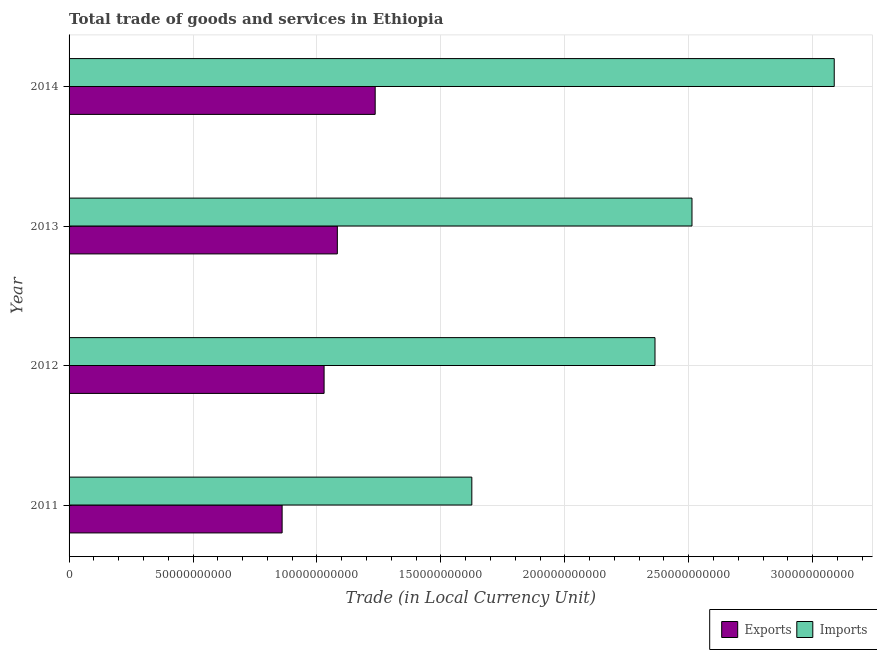How many groups of bars are there?
Give a very brief answer. 4. Are the number of bars per tick equal to the number of legend labels?
Your answer should be very brief. Yes. Are the number of bars on each tick of the Y-axis equal?
Keep it short and to the point. Yes. How many bars are there on the 3rd tick from the top?
Keep it short and to the point. 2. How many bars are there on the 4th tick from the bottom?
Offer a terse response. 2. What is the export of goods and services in 2012?
Provide a short and direct response. 1.03e+11. Across all years, what is the maximum imports of goods and services?
Keep it short and to the point. 3.09e+11. Across all years, what is the minimum imports of goods and services?
Your answer should be compact. 1.62e+11. In which year was the export of goods and services maximum?
Your answer should be very brief. 2014. In which year was the imports of goods and services minimum?
Your answer should be very brief. 2011. What is the total imports of goods and services in the graph?
Offer a very short reply. 9.59e+11. What is the difference between the imports of goods and services in 2011 and that in 2014?
Provide a succinct answer. -1.46e+11. What is the difference between the imports of goods and services in 2013 and the export of goods and services in 2012?
Offer a terse response. 1.48e+11. What is the average export of goods and services per year?
Your response must be concise. 1.05e+11. In the year 2012, what is the difference between the imports of goods and services and export of goods and services?
Ensure brevity in your answer.  1.33e+11. In how many years, is the export of goods and services greater than 40000000000 LCU?
Provide a succinct answer. 4. What is the ratio of the export of goods and services in 2013 to that in 2014?
Ensure brevity in your answer.  0.88. What is the difference between the highest and the second highest imports of goods and services?
Provide a succinct answer. 5.74e+1. What is the difference between the highest and the lowest export of goods and services?
Provide a succinct answer. 3.75e+1. In how many years, is the export of goods and services greater than the average export of goods and services taken over all years?
Offer a very short reply. 2. Is the sum of the imports of goods and services in 2011 and 2014 greater than the maximum export of goods and services across all years?
Provide a succinct answer. Yes. What does the 2nd bar from the top in 2012 represents?
Your response must be concise. Exports. What does the 2nd bar from the bottom in 2011 represents?
Your answer should be compact. Imports. How many bars are there?
Your response must be concise. 8. What is the difference between two consecutive major ticks on the X-axis?
Provide a short and direct response. 5.00e+1. Does the graph contain grids?
Offer a very short reply. Yes. How are the legend labels stacked?
Keep it short and to the point. Horizontal. What is the title of the graph?
Your response must be concise. Total trade of goods and services in Ethiopia. What is the label or title of the X-axis?
Make the answer very short. Trade (in Local Currency Unit). What is the Trade (in Local Currency Unit) of Exports in 2011?
Keep it short and to the point. 8.60e+1. What is the Trade (in Local Currency Unit) in Imports in 2011?
Give a very brief answer. 1.62e+11. What is the Trade (in Local Currency Unit) of Exports in 2012?
Make the answer very short. 1.03e+11. What is the Trade (in Local Currency Unit) in Imports in 2012?
Offer a very short reply. 2.36e+11. What is the Trade (in Local Currency Unit) in Exports in 2013?
Offer a very short reply. 1.08e+11. What is the Trade (in Local Currency Unit) in Imports in 2013?
Make the answer very short. 2.51e+11. What is the Trade (in Local Currency Unit) in Exports in 2014?
Ensure brevity in your answer.  1.23e+11. What is the Trade (in Local Currency Unit) in Imports in 2014?
Provide a succinct answer. 3.09e+11. Across all years, what is the maximum Trade (in Local Currency Unit) in Exports?
Ensure brevity in your answer.  1.23e+11. Across all years, what is the maximum Trade (in Local Currency Unit) in Imports?
Give a very brief answer. 3.09e+11. Across all years, what is the minimum Trade (in Local Currency Unit) of Exports?
Offer a terse response. 8.60e+1. Across all years, what is the minimum Trade (in Local Currency Unit) in Imports?
Make the answer very short. 1.62e+11. What is the total Trade (in Local Currency Unit) of Exports in the graph?
Your response must be concise. 4.21e+11. What is the total Trade (in Local Currency Unit) in Imports in the graph?
Give a very brief answer. 9.59e+11. What is the difference between the Trade (in Local Currency Unit) in Exports in 2011 and that in 2012?
Make the answer very short. -1.69e+1. What is the difference between the Trade (in Local Currency Unit) of Imports in 2011 and that in 2012?
Provide a short and direct response. -7.39e+1. What is the difference between the Trade (in Local Currency Unit) of Exports in 2011 and that in 2013?
Your answer should be very brief. -2.23e+1. What is the difference between the Trade (in Local Currency Unit) in Imports in 2011 and that in 2013?
Your response must be concise. -8.88e+1. What is the difference between the Trade (in Local Currency Unit) of Exports in 2011 and that in 2014?
Offer a very short reply. -3.75e+1. What is the difference between the Trade (in Local Currency Unit) in Imports in 2011 and that in 2014?
Keep it short and to the point. -1.46e+11. What is the difference between the Trade (in Local Currency Unit) of Exports in 2012 and that in 2013?
Offer a very short reply. -5.34e+09. What is the difference between the Trade (in Local Currency Unit) in Imports in 2012 and that in 2013?
Keep it short and to the point. -1.49e+1. What is the difference between the Trade (in Local Currency Unit) of Exports in 2012 and that in 2014?
Make the answer very short. -2.06e+1. What is the difference between the Trade (in Local Currency Unit) of Imports in 2012 and that in 2014?
Ensure brevity in your answer.  -7.23e+1. What is the difference between the Trade (in Local Currency Unit) of Exports in 2013 and that in 2014?
Offer a terse response. -1.53e+1. What is the difference between the Trade (in Local Currency Unit) in Imports in 2013 and that in 2014?
Provide a short and direct response. -5.74e+1. What is the difference between the Trade (in Local Currency Unit) of Exports in 2011 and the Trade (in Local Currency Unit) of Imports in 2012?
Your response must be concise. -1.50e+11. What is the difference between the Trade (in Local Currency Unit) of Exports in 2011 and the Trade (in Local Currency Unit) of Imports in 2013?
Your answer should be compact. -1.65e+11. What is the difference between the Trade (in Local Currency Unit) in Exports in 2011 and the Trade (in Local Currency Unit) in Imports in 2014?
Give a very brief answer. -2.23e+11. What is the difference between the Trade (in Local Currency Unit) in Exports in 2012 and the Trade (in Local Currency Unit) in Imports in 2013?
Your answer should be compact. -1.48e+11. What is the difference between the Trade (in Local Currency Unit) in Exports in 2012 and the Trade (in Local Currency Unit) in Imports in 2014?
Provide a short and direct response. -2.06e+11. What is the difference between the Trade (in Local Currency Unit) of Exports in 2013 and the Trade (in Local Currency Unit) of Imports in 2014?
Keep it short and to the point. -2.00e+11. What is the average Trade (in Local Currency Unit) in Exports per year?
Offer a terse response. 1.05e+11. What is the average Trade (in Local Currency Unit) of Imports per year?
Your answer should be very brief. 2.40e+11. In the year 2011, what is the difference between the Trade (in Local Currency Unit) in Exports and Trade (in Local Currency Unit) in Imports?
Give a very brief answer. -7.65e+1. In the year 2012, what is the difference between the Trade (in Local Currency Unit) of Exports and Trade (in Local Currency Unit) of Imports?
Give a very brief answer. -1.33e+11. In the year 2013, what is the difference between the Trade (in Local Currency Unit) of Exports and Trade (in Local Currency Unit) of Imports?
Your response must be concise. -1.43e+11. In the year 2014, what is the difference between the Trade (in Local Currency Unit) of Exports and Trade (in Local Currency Unit) of Imports?
Provide a succinct answer. -1.85e+11. What is the ratio of the Trade (in Local Currency Unit) of Exports in 2011 to that in 2012?
Ensure brevity in your answer.  0.84. What is the ratio of the Trade (in Local Currency Unit) of Imports in 2011 to that in 2012?
Give a very brief answer. 0.69. What is the ratio of the Trade (in Local Currency Unit) of Exports in 2011 to that in 2013?
Your response must be concise. 0.79. What is the ratio of the Trade (in Local Currency Unit) of Imports in 2011 to that in 2013?
Keep it short and to the point. 0.65. What is the ratio of the Trade (in Local Currency Unit) of Exports in 2011 to that in 2014?
Provide a short and direct response. 0.7. What is the ratio of the Trade (in Local Currency Unit) in Imports in 2011 to that in 2014?
Offer a terse response. 0.53. What is the ratio of the Trade (in Local Currency Unit) of Exports in 2012 to that in 2013?
Your response must be concise. 0.95. What is the ratio of the Trade (in Local Currency Unit) in Imports in 2012 to that in 2013?
Ensure brevity in your answer.  0.94. What is the ratio of the Trade (in Local Currency Unit) in Exports in 2012 to that in 2014?
Your answer should be compact. 0.83. What is the ratio of the Trade (in Local Currency Unit) in Imports in 2012 to that in 2014?
Provide a short and direct response. 0.77. What is the ratio of the Trade (in Local Currency Unit) of Exports in 2013 to that in 2014?
Make the answer very short. 0.88. What is the ratio of the Trade (in Local Currency Unit) in Imports in 2013 to that in 2014?
Provide a succinct answer. 0.81. What is the difference between the highest and the second highest Trade (in Local Currency Unit) of Exports?
Offer a terse response. 1.53e+1. What is the difference between the highest and the second highest Trade (in Local Currency Unit) of Imports?
Provide a succinct answer. 5.74e+1. What is the difference between the highest and the lowest Trade (in Local Currency Unit) in Exports?
Give a very brief answer. 3.75e+1. What is the difference between the highest and the lowest Trade (in Local Currency Unit) of Imports?
Give a very brief answer. 1.46e+11. 